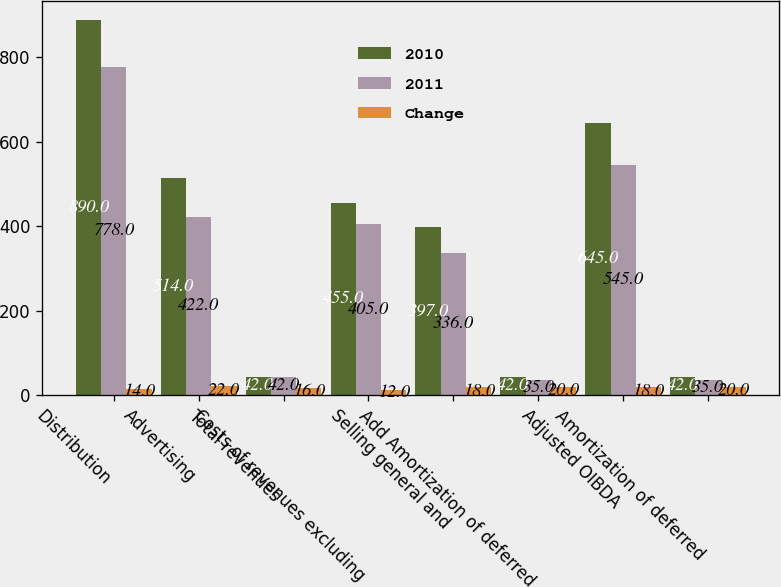Convert chart. <chart><loc_0><loc_0><loc_500><loc_500><stacked_bar_chart><ecel><fcel>Distribution<fcel>Advertising<fcel>Total revenues<fcel>Costs of revenues excluding<fcel>Selling general and<fcel>Add Amortization of deferred<fcel>Adjusted OIBDA<fcel>Amortization of deferred<nl><fcel>2010<fcel>890<fcel>514<fcel>42<fcel>455<fcel>397<fcel>42<fcel>645<fcel>42<nl><fcel>2011<fcel>778<fcel>422<fcel>42<fcel>405<fcel>336<fcel>35<fcel>545<fcel>35<nl><fcel>Change<fcel>14<fcel>22<fcel>16<fcel>12<fcel>18<fcel>20<fcel>18<fcel>20<nl></chart> 